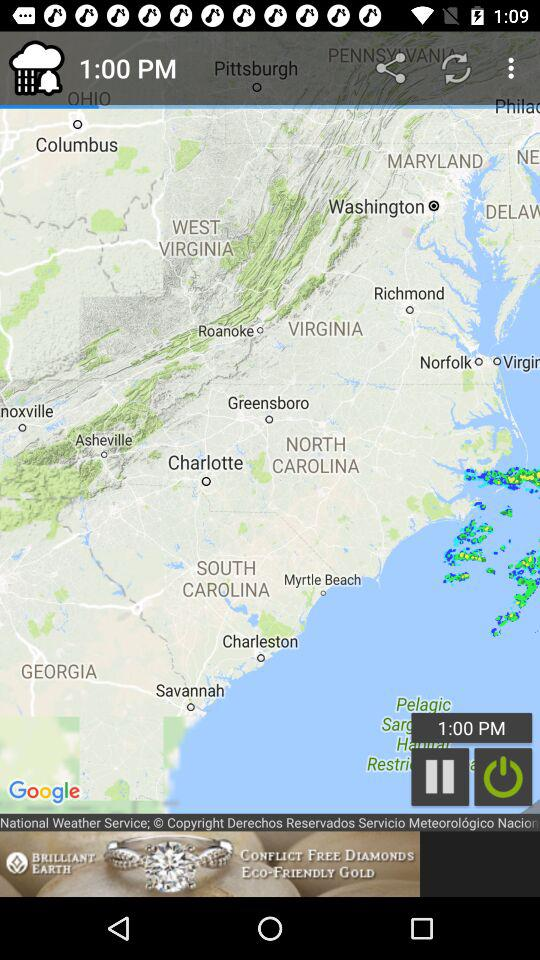What is the time on the screen? The time on the screen is 1:00 PM. 